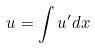<formula> <loc_0><loc_0><loc_500><loc_500>u = \int u ^ { \prime } d x</formula> 